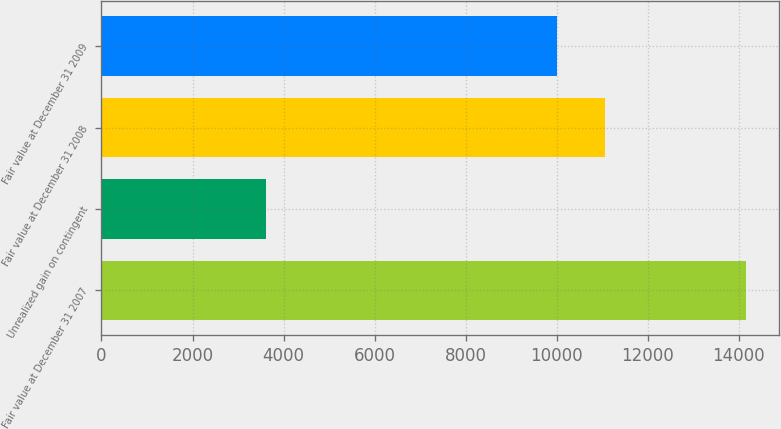Convert chart to OTSL. <chart><loc_0><loc_0><loc_500><loc_500><bar_chart><fcel>Fair value at December 31 2007<fcel>Unrealized gain on contingent<fcel>Fair value at December 31 2008<fcel>Fair value at December 31 2009<nl><fcel>14165<fcel>3616<fcel>11054.9<fcel>10000<nl></chart> 